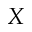<formula> <loc_0><loc_0><loc_500><loc_500>X</formula> 